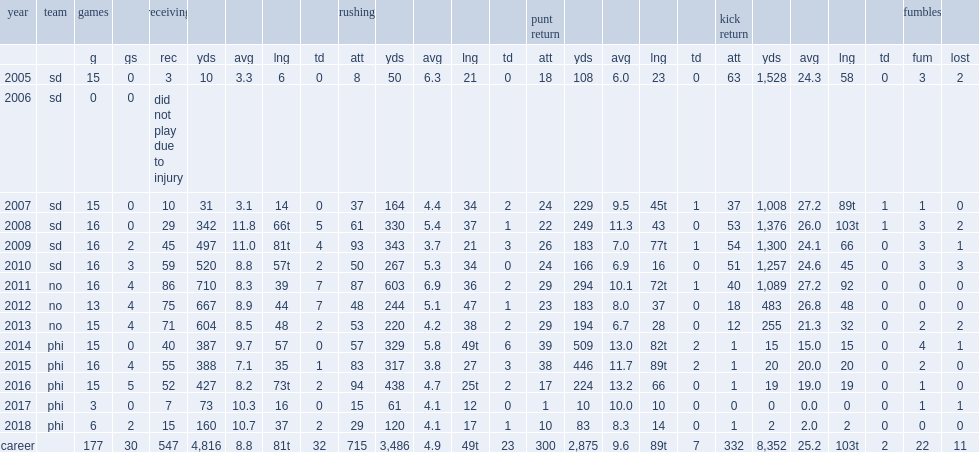How many rushing yards did sproles get in 2013? 220.0. 